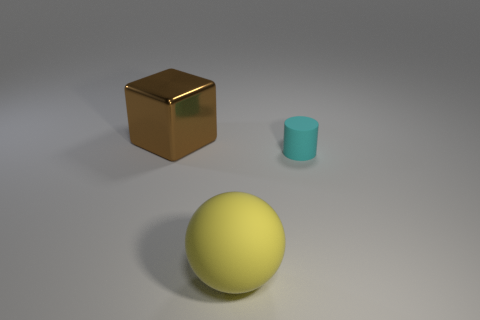Subtract all gray cubes. Subtract all red cylinders. How many cubes are left? 1 Add 3 rubber things. How many objects exist? 6 Subtract all cylinders. How many objects are left? 2 Add 1 large shiny things. How many large shiny things exist? 2 Subtract 0 purple balls. How many objects are left? 3 Subtract all tiny cylinders. Subtract all big brown blocks. How many objects are left? 1 Add 3 large yellow things. How many large yellow things are left? 4 